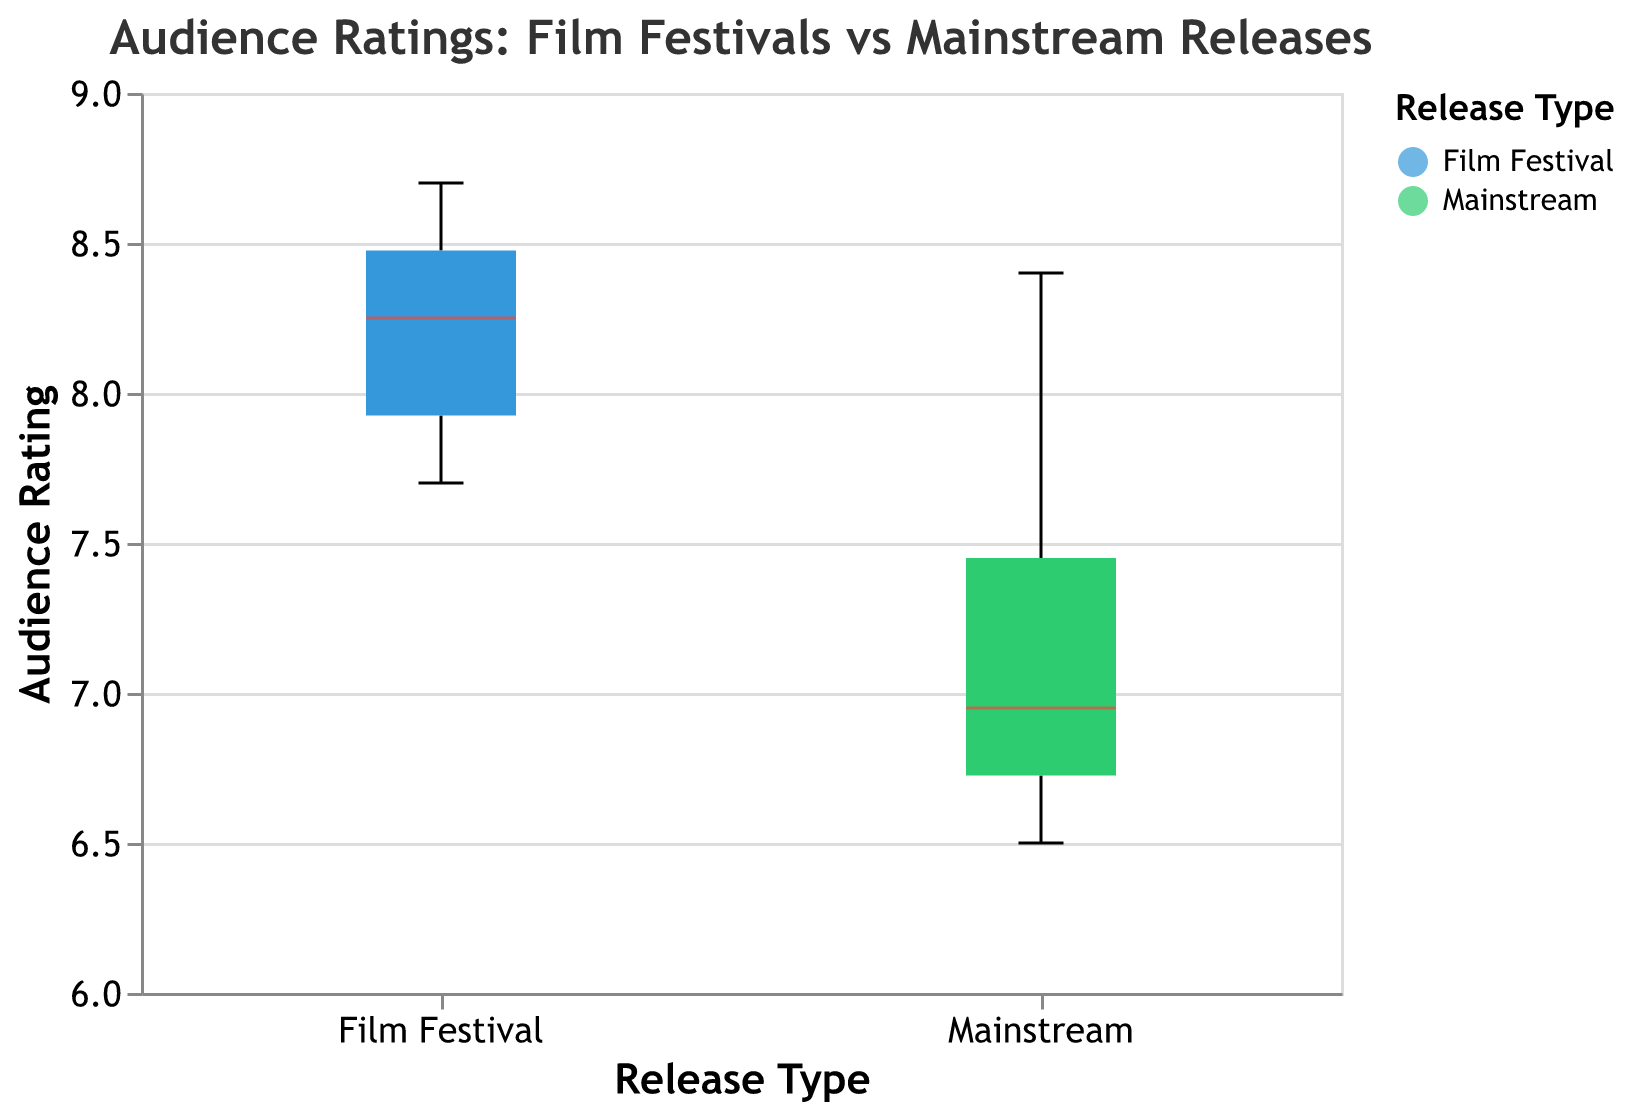What is the title of the figure? The title of the figure is located at the top and clearly states the main topic being visualized. This title provides context for what the box plot is showing.
Answer: Audience Ratings: Film Festivals vs Mainstream Releases Which release type shows the higher median audience rating? The median is typically marked by a colored line inside the box. By comparing the median lines for each type, we can determine which release type has a higher median value.
Answer: Film Festival What is the range of audience ratings for mainstream releases? The range in a box plot is indicated from the minimum to the maximum data points, excluding outliers, shown by the extended lines from the box. By looking at the box plot for mainstream releases, we find the minimum and maximum rating values.
Answer: 6.5 to 8.4 How does the variation in ratings compare between film festivals and mainstream releases? Variation in a box plot is indicated by the length of the box and the whiskers. Longer boxes and whiskers signify higher variation. By comparing these elements between the two categories, we can describe the difference in variation.
Answer: Film Festivals have a smaller variation Which film release type has more data points shown as outliers? Outliers in a box plot are usually indicated by small dots outside the box and whiskers. By counting these outliers for each release type, we can determine which type has more.
Answer: Mainstream What is the interquartile range (IQR) for film festival releases? The interquartile range is the difference between the upper quartile (Q3) and the lower quartile (Q1), which are the top and bottom edges of the box. By reading the values of these quartiles from the plot, we can compute the IQR.
Answer: 7.9 (Q1) to 8.5 (Q3) How does the lowest rating for mainstream releases compare to the lowest rating for film festival releases? The lowest ratings are the bottom ends of the whiskers. By identifying these endpoints for each release type, we can compare them directly.
Answer: Mainstream: 6.5, Film Festival: 7.7 What is the difference between the highest audience rating for film festival releases and that for mainstream releases? The highest rating for each release type is at the top end of the whiskers or outliers. By locating these points for both types, we can compute the difference.
Answer: 8.7 (Film Festival) - 8.4 (Mainstream) = 0.3 Which type of release has a higher upper quartile value? The upper quartile (Q3) is represented by the top edge of the box. By comparing the heights of the top edges in both boxes, we can determine which type has the higher Q3 value.
Answer: Film Festival 